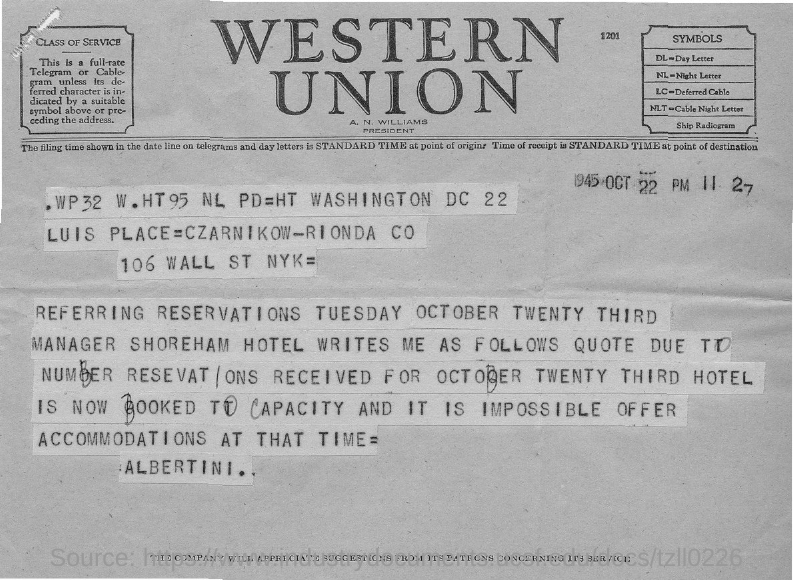Who is the president of Western Union?
Keep it short and to the point. A. n. williams. What does LC stand for in this document?
Offer a terse response. Deferred cable. What does DL stand for in this document?
Offer a terse response. Day letter. When is the document dated?
Your answer should be very brief. 1945 oct 22. 